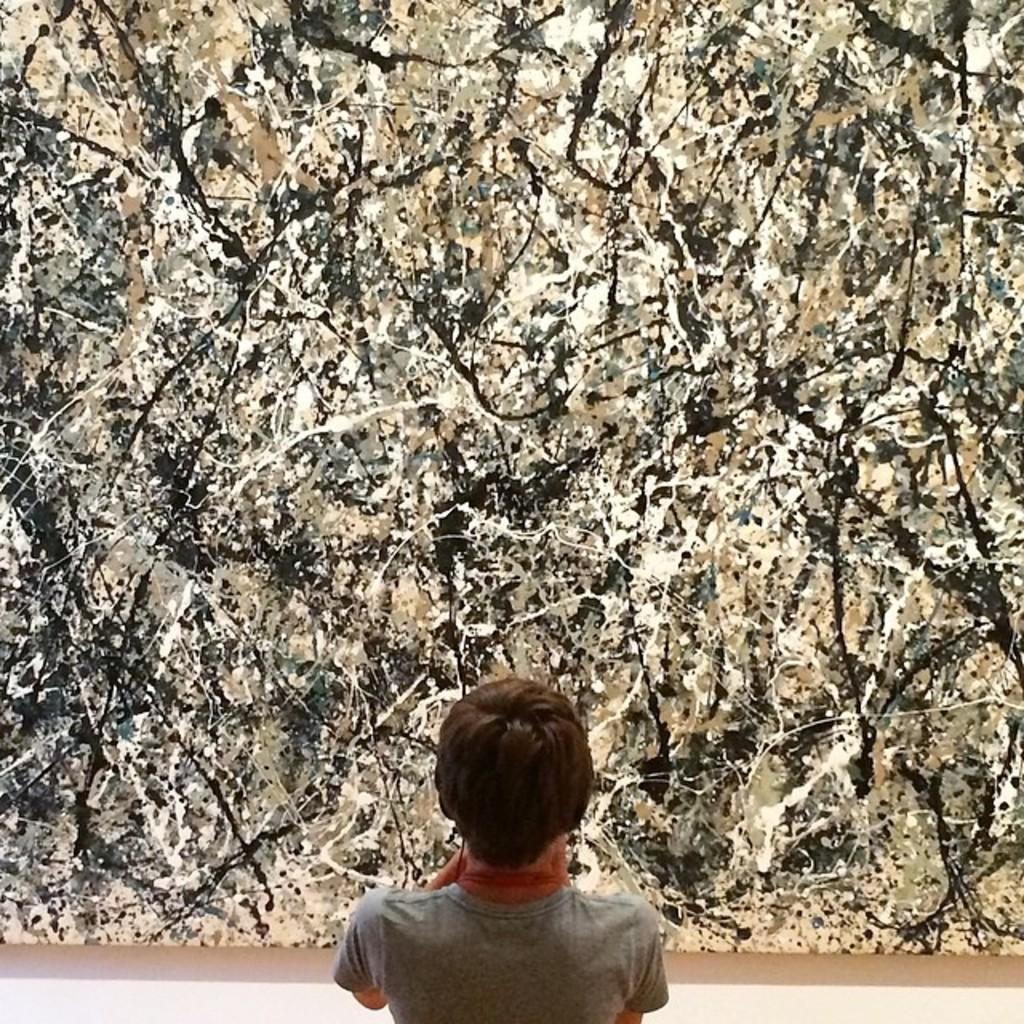In one or two sentences, can you explain what this image depicts? In the image we can see a person wearing clothes, this is a painting. 